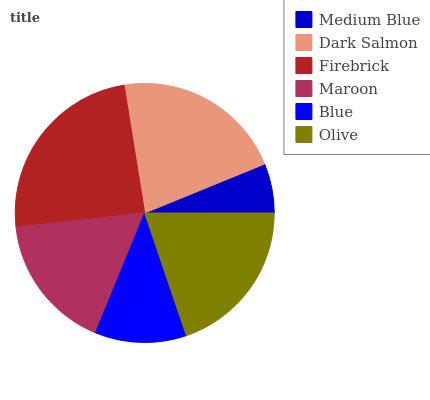Is Medium Blue the minimum?
Answer yes or no. Yes. Is Firebrick the maximum?
Answer yes or no. Yes. Is Dark Salmon the minimum?
Answer yes or no. No. Is Dark Salmon the maximum?
Answer yes or no. No. Is Dark Salmon greater than Medium Blue?
Answer yes or no. Yes. Is Medium Blue less than Dark Salmon?
Answer yes or no. Yes. Is Medium Blue greater than Dark Salmon?
Answer yes or no. No. Is Dark Salmon less than Medium Blue?
Answer yes or no. No. Is Olive the high median?
Answer yes or no. Yes. Is Maroon the low median?
Answer yes or no. Yes. Is Firebrick the high median?
Answer yes or no. No. Is Dark Salmon the low median?
Answer yes or no. No. 